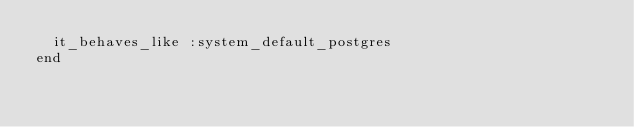Convert code to text. <code><loc_0><loc_0><loc_500><loc_500><_Ruby_>  it_behaves_like :system_default_postgres
end
</code> 